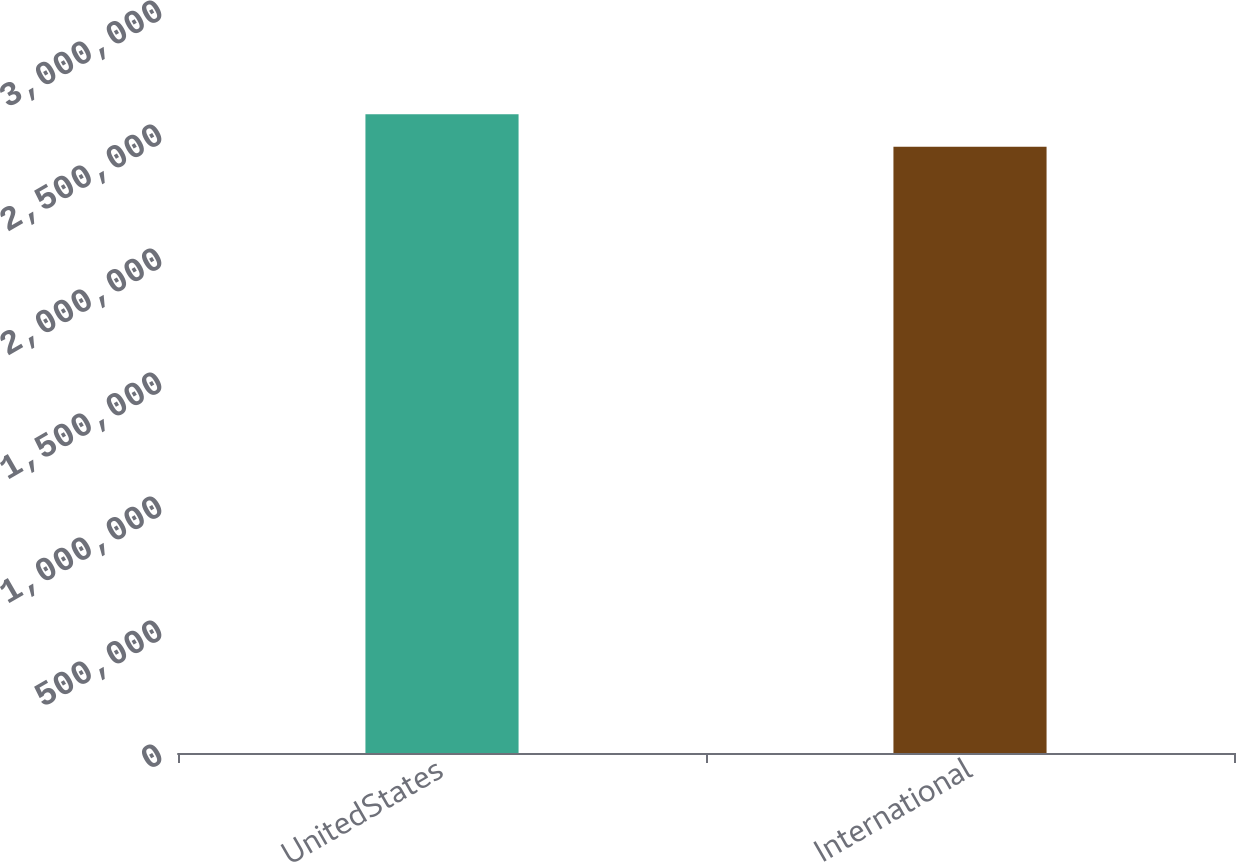Convert chart to OTSL. <chart><loc_0><loc_0><loc_500><loc_500><bar_chart><fcel>UnitedStates<fcel>International<nl><fcel>2.5757e+06<fcel>2.44413e+06<nl></chart> 